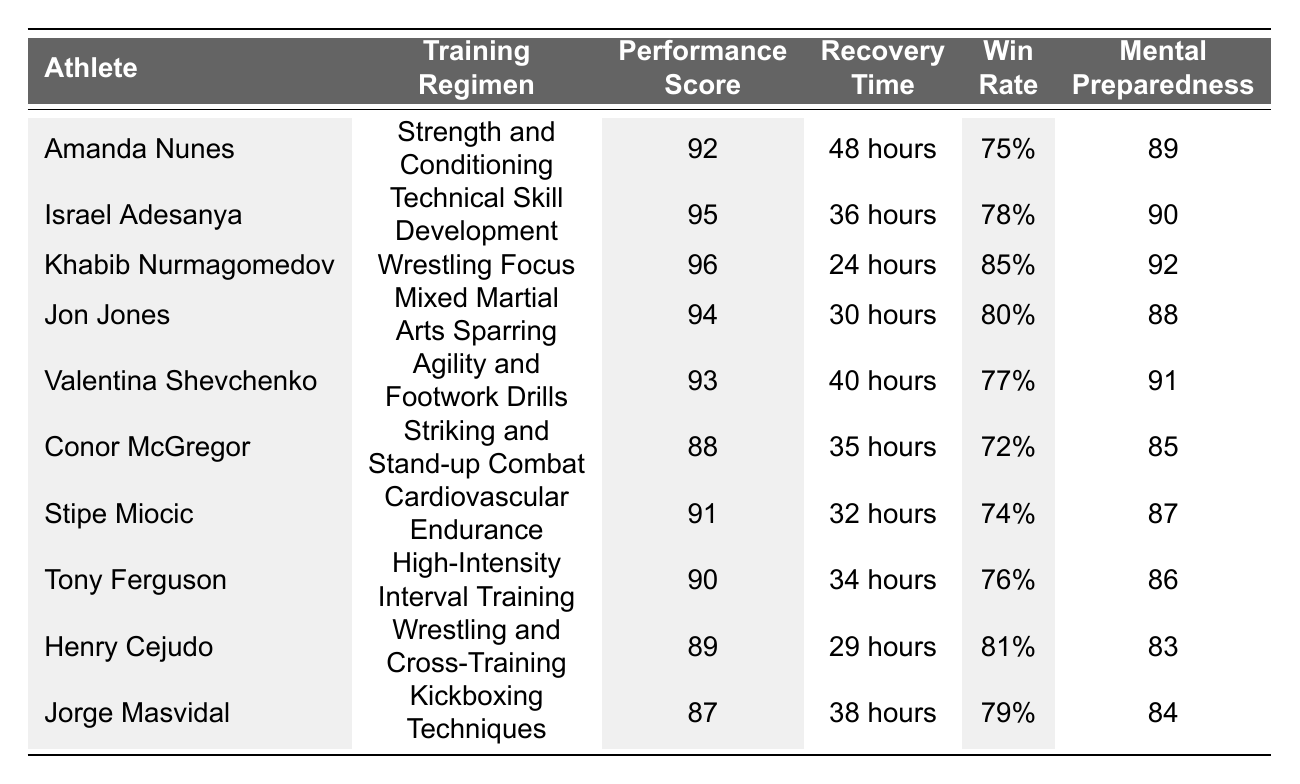What is the highest Performance Score among the athletes? By examining the column titled "Performance Score," Khabib Nurmagomedov has the highest score of 96.
Answer: 96 Which athlete has the longest Recovery Time? Looking at the "Recovery Time" column, Amanda Nunes has the longest recovery time listed, which is 48 hours.
Answer: 48 hours What is the average Win Rate of the athletes in the table? To find the average, we sum all the Win Rates (75 + 78 + 85 + 80 + 77 + 72 + 74 + 76 + 81 + 79 = 786) and divide by the number of athletes (10), resulting in 786 / 10 = 78.6.
Answer: 78.6 Is there any athlete with a Mental Preparedness Score lower than 85? By reviewing the "Mental Preparedness Score" column, Conor McGregor (85), Henry Cejudo (83), and Jorge Masvidal (84) have scores below 85, indicating that there are athletes with lower scores.
Answer: Yes Which training regimen has the highest average Performance Score? Calculating the Performance Scores by each training regimen: Strength and Conditioning (92), Technical Skill Development (95), Wrestling Focus (96), Mixed Martial Arts Sparring (94), Agility and Footwork Drills (93), Striking and Stand-up Combat (88), Cardiovascular Endurance (91), High-Intensity Interval Training (90), Wrestling and Cross-Training (89), Kickboxing Techniques (87). The average score for each regimen is calculated and Wrestling Focus has the highest average of 96.
Answer: Wrestling Focus What is the difference between the highest and lowest Win Rate? The highest Win Rate is 85% (Khabib Nurmagomedov) and the lowest is 72% (Conor McGregor). The difference is 85 - 72 = 13%.
Answer: 13% Which athlete scored both a Performance Score and a Mental Preparedness Score above 90? Checking both scores reveals that Khabib Nurmagomedov (96, 92), Israel Adesanya (95, 90), and Valentina Shevchenko (93, 91) meet the criteria.
Answer: Khabib Nurmagomedov, Israel Adesanya, Valentina Shevchenko How many athletes have a Win Rate of 80% or higher? The athletes meeting this criterion are Khabib Nurmagomedov (85%), Jon Jones (80%), and Henry Cejudo (81%), making a total of 3 athletes.
Answer: 3 What is the total Performance Score of all athletes? The sum of the Performance Scores is (92 + 95 + 96 + 94 + 93 + 88 + 91 + 90 + 89 + 87 = 915).
Answer: 915 